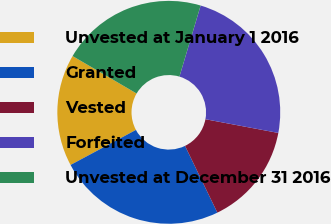<chart> <loc_0><loc_0><loc_500><loc_500><pie_chart><fcel>Unvested at January 1 2016<fcel>Granted<fcel>Vested<fcel>Forfeited<fcel>Unvested at December 31 2016<nl><fcel>16.25%<fcel>24.35%<fcel>14.86%<fcel>23.35%<fcel>21.19%<nl></chart> 